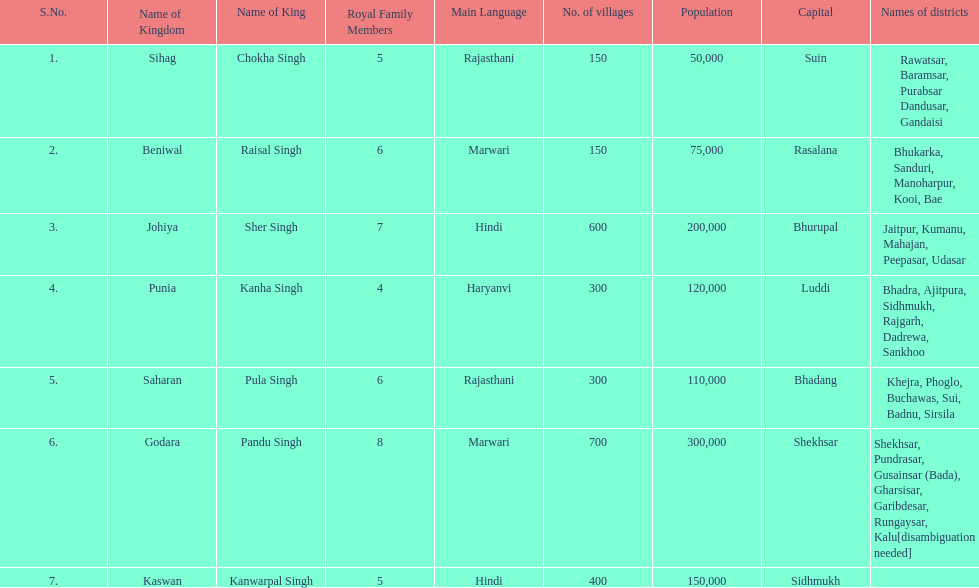What is the number of kingdoms that have more than 300 villages? 3. 